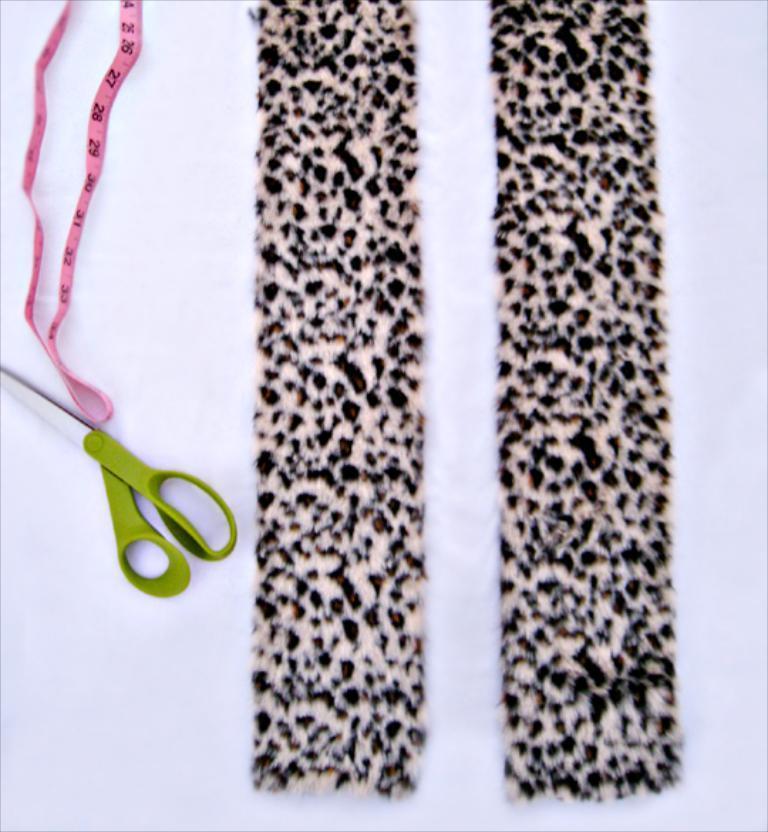Could you give a brief overview of what you see in this image? In this image I can see a green scissors and pink color tape. I can see a cloth which is in cream and black color. They are on the white color surface. 